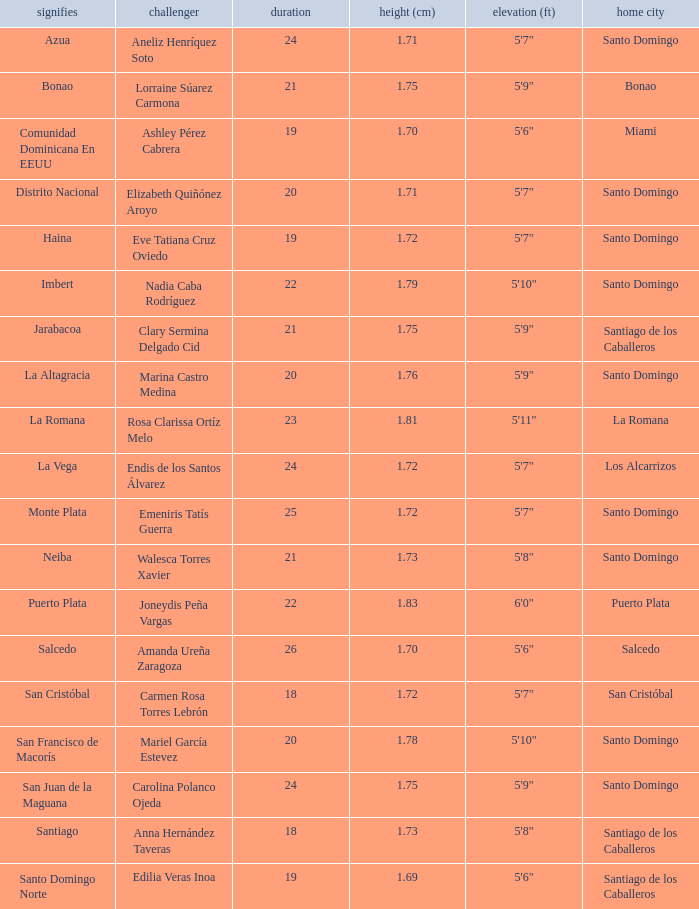Name the represents for los alcarrizos La Vega. 